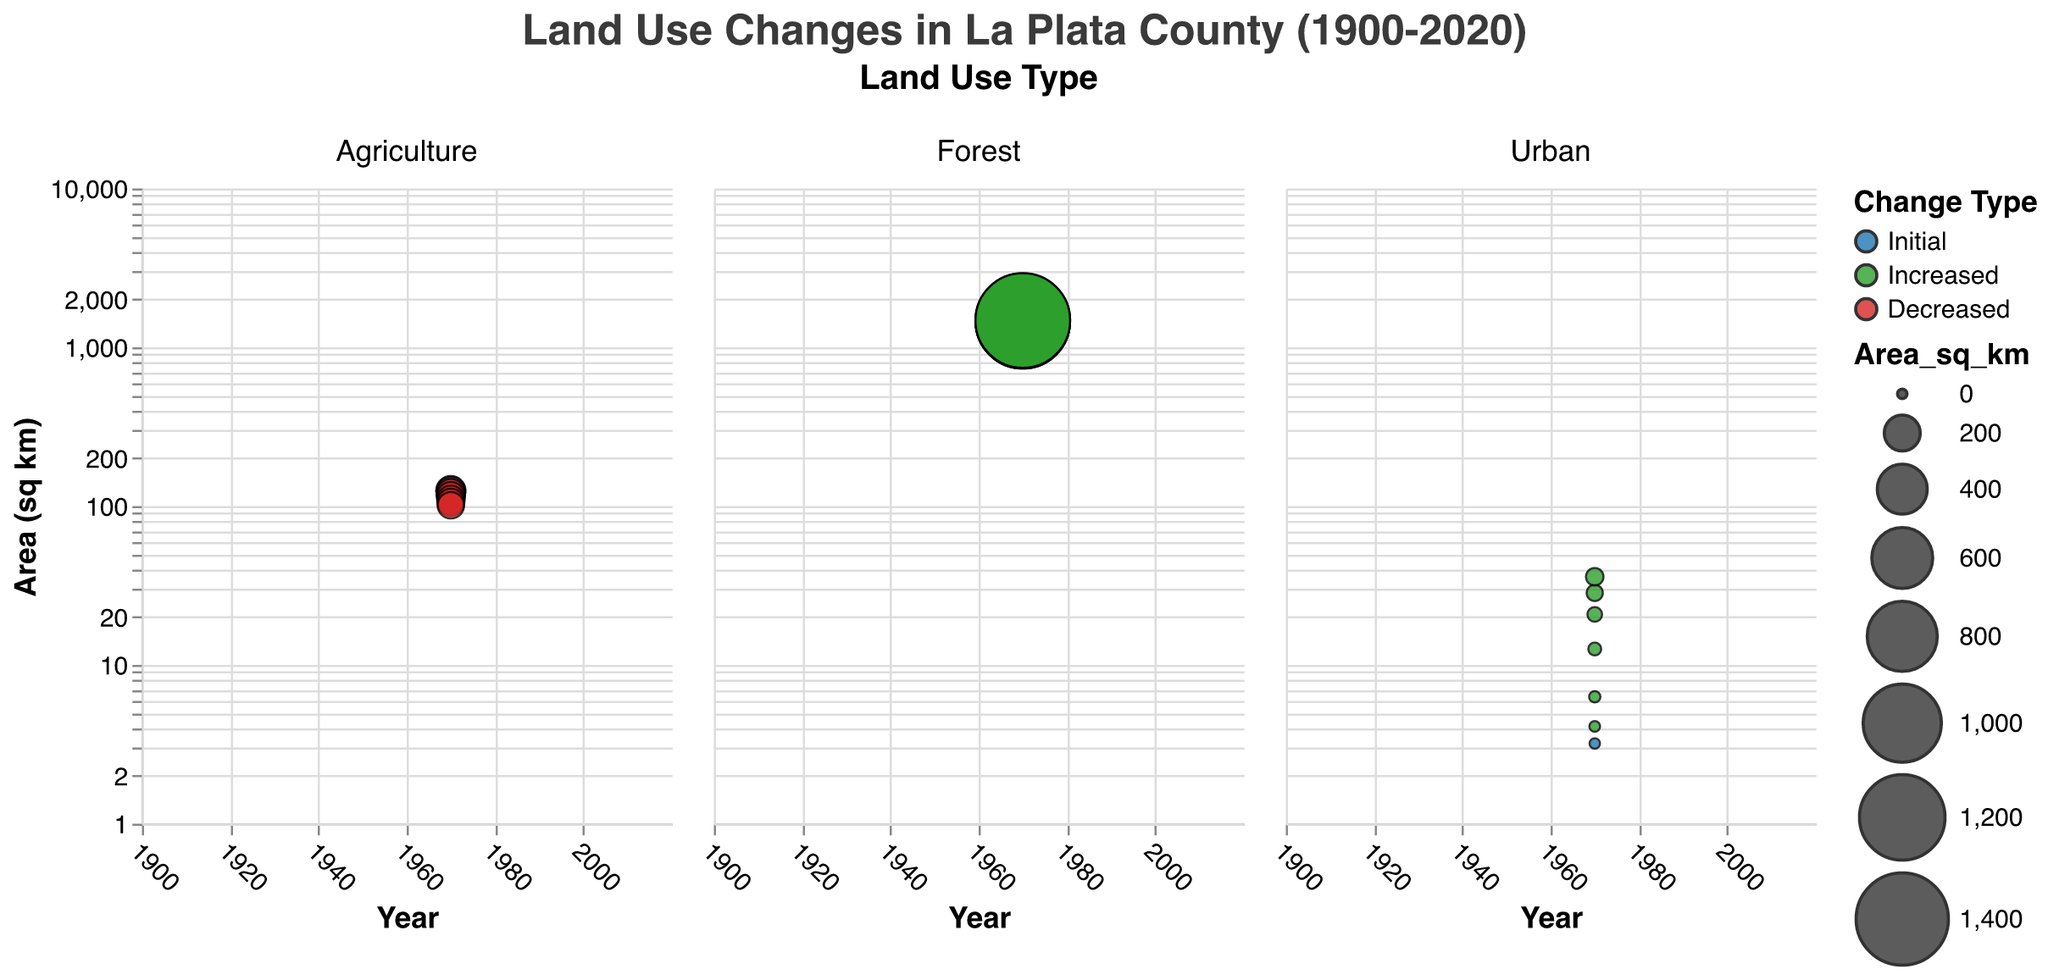What are the three land use types shown in the figure? The three land use types can be identified from the columns of the faceted subplot. These land use types are "Agriculture," "Forest," and "Urban."
Answer: Agriculture, Forest, Urban How has the area of agricultural land in Animas Valley changed from 1900 to 2020? To determine the change in the area of agricultural land, look at the agricultural land subplot and compare the bubble sizes for 1900 and 2020. The bubble for 1900 is larger than that for 2020, indicating a decrease.
Answer: Decreased In which year did the urban area in Durango experience the highest increase compared to the previous recorded year? To find the year with the highest increase, identify the urban subplot and compare the increases in bubble sizes between consecutive years. The largest increase is between 1940 and 1960.
Answer: 1960 What's the change type and area for the forest land use in 1960? Locate the data points for the forest subplot in 1960. The bubble's color indicates the change type, and the bubble's size represents the area. In 1960, the forest land use has a "Decreased" change type and 1458.7 sq km area.
Answer: Decreased, 1458.7 sq km Which land use type has shown a consistent increase in area throughout all years? Compare the bubbles in all the subplots. The forest land use subplot shows consistent increases in the area from 1920 to 2020.
Answer: Forest By how much did the urban area in Durango increase from 1980 to 2000? Check the values for the urban area in 1980 and 2000 in the urban subplot. The area increased from 20.8 sq km to 28.4 sq km. The increase is 28.4 - 20.8 = 7.6 sq km.
Answer: 7.6 sq km Which prominent location is associated with the largest forest area in 2020? Identify the forest subplot and look for the largest bubble in 2020. The prominent location listed in the tooltip for this bubble is "San Juan National Forest."
Answer: San Juan National Forest What is the general trend in the agricultural land use area in Animas Valley over the 120 years? Observe the agricultural land subplot. The sizes of the bubbles from 1900 to 2020 show a decreasing trend in agricultural land use area.
Answer: Decreasing How does the area of urban land use in Durango in 2020 compare to that in 1900? Compare the bubble sizes in the urban subplot for 1900 and 2020. The bubble in 2020 is significantly larger than in 1900, indicating an increase in urban land area.
Answer: Increased 